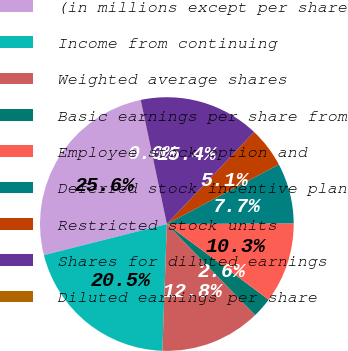<chart> <loc_0><loc_0><loc_500><loc_500><pie_chart><fcel>(in millions except per share<fcel>Income from continuing<fcel>Weighted average shares<fcel>Basic earnings per share from<fcel>Employee stock option and<fcel>Deferred stock incentive plan<fcel>Restricted stock units<fcel>Shares for diluted earnings<fcel>Diluted earnings per share<nl><fcel>25.62%<fcel>20.5%<fcel>12.82%<fcel>2.58%<fcel>10.26%<fcel>7.7%<fcel>5.14%<fcel>15.38%<fcel>0.02%<nl></chart> 